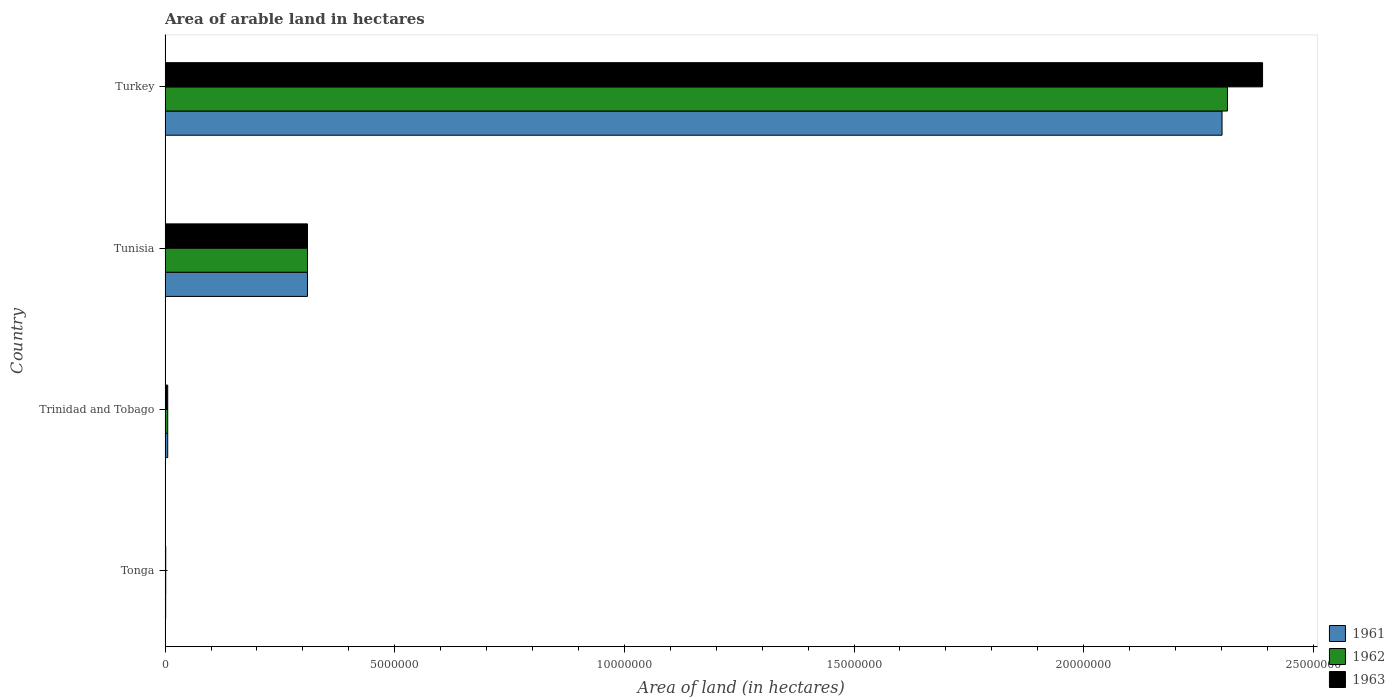How many different coloured bars are there?
Your response must be concise. 3. How many groups of bars are there?
Provide a short and direct response. 4. How many bars are there on the 1st tick from the top?
Provide a short and direct response. 3. What is the label of the 3rd group of bars from the top?
Ensure brevity in your answer.  Trinidad and Tobago. What is the total arable land in 1962 in Turkey?
Provide a succinct answer. 2.31e+07. Across all countries, what is the maximum total arable land in 1962?
Offer a terse response. 2.31e+07. Across all countries, what is the minimum total arable land in 1962?
Your answer should be compact. 1.40e+04. In which country was the total arable land in 1962 maximum?
Ensure brevity in your answer.  Turkey. In which country was the total arable land in 1961 minimum?
Provide a short and direct response. Tonga. What is the total total arable land in 1963 in the graph?
Provide a short and direct response. 2.71e+07. What is the difference between the total arable land in 1963 in Trinidad and Tobago and that in Turkey?
Your answer should be very brief. -2.38e+07. What is the difference between the total arable land in 1961 in Tonga and the total arable land in 1963 in Turkey?
Make the answer very short. -2.39e+07. What is the average total arable land in 1961 per country?
Make the answer very short. 6.55e+06. What is the difference between the total arable land in 1962 and total arable land in 1961 in Trinidad and Tobago?
Provide a short and direct response. 0. In how many countries, is the total arable land in 1962 greater than 5000000 hectares?
Your response must be concise. 1. What is the ratio of the total arable land in 1962 in Tonga to that in Tunisia?
Keep it short and to the point. 0. Is the difference between the total arable land in 1962 in Tonga and Tunisia greater than the difference between the total arable land in 1961 in Tonga and Tunisia?
Make the answer very short. Yes. What is the difference between the highest and the second highest total arable land in 1963?
Your answer should be compact. 2.08e+07. What is the difference between the highest and the lowest total arable land in 1963?
Provide a short and direct response. 2.39e+07. In how many countries, is the total arable land in 1961 greater than the average total arable land in 1961 taken over all countries?
Offer a terse response. 1. What does the 1st bar from the top in Trinidad and Tobago represents?
Make the answer very short. 1963. How many bars are there?
Your response must be concise. 12. Are the values on the major ticks of X-axis written in scientific E-notation?
Your response must be concise. No. Does the graph contain any zero values?
Your answer should be very brief. No. Does the graph contain grids?
Keep it short and to the point. No. Where does the legend appear in the graph?
Offer a very short reply. Bottom right. How many legend labels are there?
Keep it short and to the point. 3. What is the title of the graph?
Your answer should be very brief. Area of arable land in hectares. What is the label or title of the X-axis?
Your answer should be compact. Area of land (in hectares). What is the label or title of the Y-axis?
Your answer should be compact. Country. What is the Area of land (in hectares) in 1961 in Tonga?
Give a very brief answer. 1.20e+04. What is the Area of land (in hectares) in 1962 in Tonga?
Your answer should be very brief. 1.40e+04. What is the Area of land (in hectares) of 1963 in Tonga?
Provide a short and direct response. 1.40e+04. What is the Area of land (in hectares) in 1961 in Trinidad and Tobago?
Your response must be concise. 5.70e+04. What is the Area of land (in hectares) of 1962 in Trinidad and Tobago?
Offer a terse response. 5.70e+04. What is the Area of land (in hectares) of 1963 in Trinidad and Tobago?
Keep it short and to the point. 5.70e+04. What is the Area of land (in hectares) in 1961 in Tunisia?
Give a very brief answer. 3.10e+06. What is the Area of land (in hectares) in 1962 in Tunisia?
Your answer should be compact. 3.10e+06. What is the Area of land (in hectares) of 1963 in Tunisia?
Make the answer very short. 3.10e+06. What is the Area of land (in hectares) of 1961 in Turkey?
Your answer should be very brief. 2.30e+07. What is the Area of land (in hectares) of 1962 in Turkey?
Provide a succinct answer. 2.31e+07. What is the Area of land (in hectares) in 1963 in Turkey?
Give a very brief answer. 2.39e+07. Across all countries, what is the maximum Area of land (in hectares) in 1961?
Your response must be concise. 2.30e+07. Across all countries, what is the maximum Area of land (in hectares) of 1962?
Provide a succinct answer. 2.31e+07. Across all countries, what is the maximum Area of land (in hectares) of 1963?
Your response must be concise. 2.39e+07. Across all countries, what is the minimum Area of land (in hectares) of 1961?
Provide a succinct answer. 1.20e+04. Across all countries, what is the minimum Area of land (in hectares) of 1962?
Provide a succinct answer. 1.40e+04. Across all countries, what is the minimum Area of land (in hectares) in 1963?
Give a very brief answer. 1.40e+04. What is the total Area of land (in hectares) in 1961 in the graph?
Offer a terse response. 2.62e+07. What is the total Area of land (in hectares) of 1962 in the graph?
Provide a short and direct response. 2.63e+07. What is the total Area of land (in hectares) of 1963 in the graph?
Keep it short and to the point. 2.71e+07. What is the difference between the Area of land (in hectares) of 1961 in Tonga and that in Trinidad and Tobago?
Keep it short and to the point. -4.50e+04. What is the difference between the Area of land (in hectares) in 1962 in Tonga and that in Trinidad and Tobago?
Keep it short and to the point. -4.30e+04. What is the difference between the Area of land (in hectares) of 1963 in Tonga and that in Trinidad and Tobago?
Provide a succinct answer. -4.30e+04. What is the difference between the Area of land (in hectares) of 1961 in Tonga and that in Tunisia?
Offer a terse response. -3.09e+06. What is the difference between the Area of land (in hectares) of 1962 in Tonga and that in Tunisia?
Give a very brief answer. -3.09e+06. What is the difference between the Area of land (in hectares) in 1963 in Tonga and that in Tunisia?
Your answer should be very brief. -3.09e+06. What is the difference between the Area of land (in hectares) in 1961 in Tonga and that in Turkey?
Provide a succinct answer. -2.30e+07. What is the difference between the Area of land (in hectares) of 1962 in Tonga and that in Turkey?
Offer a very short reply. -2.31e+07. What is the difference between the Area of land (in hectares) in 1963 in Tonga and that in Turkey?
Offer a very short reply. -2.39e+07. What is the difference between the Area of land (in hectares) in 1961 in Trinidad and Tobago and that in Tunisia?
Offer a very short reply. -3.04e+06. What is the difference between the Area of land (in hectares) in 1962 in Trinidad and Tobago and that in Tunisia?
Your answer should be very brief. -3.04e+06. What is the difference between the Area of land (in hectares) in 1963 in Trinidad and Tobago and that in Tunisia?
Offer a terse response. -3.04e+06. What is the difference between the Area of land (in hectares) of 1961 in Trinidad and Tobago and that in Turkey?
Provide a succinct answer. -2.30e+07. What is the difference between the Area of land (in hectares) of 1962 in Trinidad and Tobago and that in Turkey?
Provide a short and direct response. -2.31e+07. What is the difference between the Area of land (in hectares) of 1963 in Trinidad and Tobago and that in Turkey?
Keep it short and to the point. -2.38e+07. What is the difference between the Area of land (in hectares) of 1961 in Tunisia and that in Turkey?
Ensure brevity in your answer.  -1.99e+07. What is the difference between the Area of land (in hectares) in 1962 in Tunisia and that in Turkey?
Ensure brevity in your answer.  -2.00e+07. What is the difference between the Area of land (in hectares) in 1963 in Tunisia and that in Turkey?
Offer a very short reply. -2.08e+07. What is the difference between the Area of land (in hectares) in 1961 in Tonga and the Area of land (in hectares) in 1962 in Trinidad and Tobago?
Offer a terse response. -4.50e+04. What is the difference between the Area of land (in hectares) in 1961 in Tonga and the Area of land (in hectares) in 1963 in Trinidad and Tobago?
Offer a very short reply. -4.50e+04. What is the difference between the Area of land (in hectares) in 1962 in Tonga and the Area of land (in hectares) in 1963 in Trinidad and Tobago?
Give a very brief answer. -4.30e+04. What is the difference between the Area of land (in hectares) of 1961 in Tonga and the Area of land (in hectares) of 1962 in Tunisia?
Your answer should be very brief. -3.09e+06. What is the difference between the Area of land (in hectares) of 1961 in Tonga and the Area of land (in hectares) of 1963 in Tunisia?
Offer a very short reply. -3.09e+06. What is the difference between the Area of land (in hectares) in 1962 in Tonga and the Area of land (in hectares) in 1963 in Tunisia?
Offer a terse response. -3.09e+06. What is the difference between the Area of land (in hectares) of 1961 in Tonga and the Area of land (in hectares) of 1962 in Turkey?
Offer a terse response. -2.31e+07. What is the difference between the Area of land (in hectares) of 1961 in Tonga and the Area of land (in hectares) of 1963 in Turkey?
Offer a very short reply. -2.39e+07. What is the difference between the Area of land (in hectares) in 1962 in Tonga and the Area of land (in hectares) in 1963 in Turkey?
Give a very brief answer. -2.39e+07. What is the difference between the Area of land (in hectares) of 1961 in Trinidad and Tobago and the Area of land (in hectares) of 1962 in Tunisia?
Provide a short and direct response. -3.04e+06. What is the difference between the Area of land (in hectares) in 1961 in Trinidad and Tobago and the Area of land (in hectares) in 1963 in Tunisia?
Give a very brief answer. -3.04e+06. What is the difference between the Area of land (in hectares) in 1962 in Trinidad and Tobago and the Area of land (in hectares) in 1963 in Tunisia?
Give a very brief answer. -3.04e+06. What is the difference between the Area of land (in hectares) of 1961 in Trinidad and Tobago and the Area of land (in hectares) of 1962 in Turkey?
Give a very brief answer. -2.31e+07. What is the difference between the Area of land (in hectares) in 1961 in Trinidad and Tobago and the Area of land (in hectares) in 1963 in Turkey?
Offer a terse response. -2.38e+07. What is the difference between the Area of land (in hectares) of 1962 in Trinidad and Tobago and the Area of land (in hectares) of 1963 in Turkey?
Make the answer very short. -2.38e+07. What is the difference between the Area of land (in hectares) of 1961 in Tunisia and the Area of land (in hectares) of 1962 in Turkey?
Keep it short and to the point. -2.00e+07. What is the difference between the Area of land (in hectares) of 1961 in Tunisia and the Area of land (in hectares) of 1963 in Turkey?
Your answer should be very brief. -2.08e+07. What is the difference between the Area of land (in hectares) in 1962 in Tunisia and the Area of land (in hectares) in 1963 in Turkey?
Your answer should be very brief. -2.08e+07. What is the average Area of land (in hectares) of 1961 per country?
Offer a very short reply. 6.55e+06. What is the average Area of land (in hectares) in 1962 per country?
Ensure brevity in your answer.  6.58e+06. What is the average Area of land (in hectares) of 1963 per country?
Your answer should be compact. 6.77e+06. What is the difference between the Area of land (in hectares) of 1961 and Area of land (in hectares) of 1962 in Tonga?
Your answer should be very brief. -2000. What is the difference between the Area of land (in hectares) of 1961 and Area of land (in hectares) of 1963 in Tonga?
Offer a terse response. -2000. What is the difference between the Area of land (in hectares) in 1961 and Area of land (in hectares) in 1962 in Trinidad and Tobago?
Offer a very short reply. 0. What is the difference between the Area of land (in hectares) of 1961 and Area of land (in hectares) of 1963 in Trinidad and Tobago?
Offer a terse response. 0. What is the difference between the Area of land (in hectares) in 1961 and Area of land (in hectares) in 1963 in Tunisia?
Provide a short and direct response. 0. What is the difference between the Area of land (in hectares) of 1962 and Area of land (in hectares) of 1963 in Tunisia?
Your answer should be compact. 0. What is the difference between the Area of land (in hectares) in 1961 and Area of land (in hectares) in 1962 in Turkey?
Provide a succinct answer. -1.18e+05. What is the difference between the Area of land (in hectares) in 1961 and Area of land (in hectares) in 1963 in Turkey?
Keep it short and to the point. -8.82e+05. What is the difference between the Area of land (in hectares) in 1962 and Area of land (in hectares) in 1963 in Turkey?
Provide a succinct answer. -7.64e+05. What is the ratio of the Area of land (in hectares) in 1961 in Tonga to that in Trinidad and Tobago?
Offer a very short reply. 0.21. What is the ratio of the Area of land (in hectares) in 1962 in Tonga to that in Trinidad and Tobago?
Keep it short and to the point. 0.25. What is the ratio of the Area of land (in hectares) of 1963 in Tonga to that in Trinidad and Tobago?
Provide a short and direct response. 0.25. What is the ratio of the Area of land (in hectares) of 1961 in Tonga to that in Tunisia?
Provide a succinct answer. 0. What is the ratio of the Area of land (in hectares) in 1962 in Tonga to that in Tunisia?
Your answer should be compact. 0. What is the ratio of the Area of land (in hectares) of 1963 in Tonga to that in Tunisia?
Keep it short and to the point. 0. What is the ratio of the Area of land (in hectares) in 1962 in Tonga to that in Turkey?
Keep it short and to the point. 0. What is the ratio of the Area of land (in hectares) of 1963 in Tonga to that in Turkey?
Give a very brief answer. 0. What is the ratio of the Area of land (in hectares) of 1961 in Trinidad and Tobago to that in Tunisia?
Make the answer very short. 0.02. What is the ratio of the Area of land (in hectares) of 1962 in Trinidad and Tobago to that in Tunisia?
Provide a succinct answer. 0.02. What is the ratio of the Area of land (in hectares) in 1963 in Trinidad and Tobago to that in Tunisia?
Provide a succinct answer. 0.02. What is the ratio of the Area of land (in hectares) in 1961 in Trinidad and Tobago to that in Turkey?
Offer a terse response. 0. What is the ratio of the Area of land (in hectares) in 1962 in Trinidad and Tobago to that in Turkey?
Your answer should be very brief. 0. What is the ratio of the Area of land (in hectares) in 1963 in Trinidad and Tobago to that in Turkey?
Offer a terse response. 0. What is the ratio of the Area of land (in hectares) of 1961 in Tunisia to that in Turkey?
Your response must be concise. 0.13. What is the ratio of the Area of land (in hectares) in 1962 in Tunisia to that in Turkey?
Offer a terse response. 0.13. What is the ratio of the Area of land (in hectares) in 1963 in Tunisia to that in Turkey?
Ensure brevity in your answer.  0.13. What is the difference between the highest and the second highest Area of land (in hectares) in 1961?
Offer a very short reply. 1.99e+07. What is the difference between the highest and the second highest Area of land (in hectares) in 1962?
Keep it short and to the point. 2.00e+07. What is the difference between the highest and the second highest Area of land (in hectares) in 1963?
Offer a terse response. 2.08e+07. What is the difference between the highest and the lowest Area of land (in hectares) in 1961?
Make the answer very short. 2.30e+07. What is the difference between the highest and the lowest Area of land (in hectares) of 1962?
Offer a terse response. 2.31e+07. What is the difference between the highest and the lowest Area of land (in hectares) in 1963?
Give a very brief answer. 2.39e+07. 